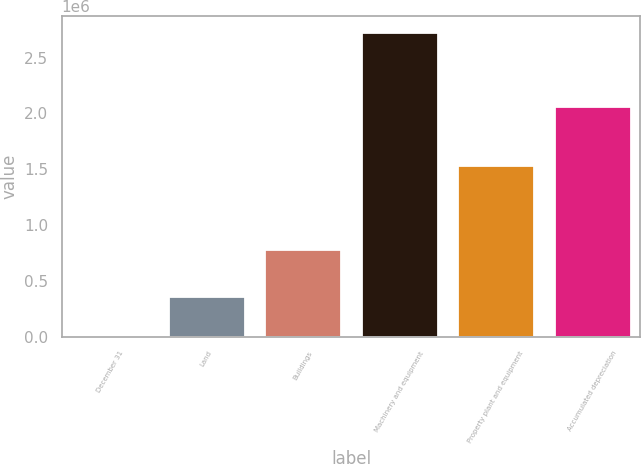Convert chart. <chart><loc_0><loc_0><loc_500><loc_500><bar_chart><fcel>December 31<fcel>Land<fcel>Buildings<fcel>Machinery and equipment<fcel>Property plant and equipment<fcel>Accumulated depreciation<nl><fcel>2007<fcel>362451<fcel>788267<fcel>2.73158e+06<fcel>1.53972e+06<fcel>2.06673e+06<nl></chart> 